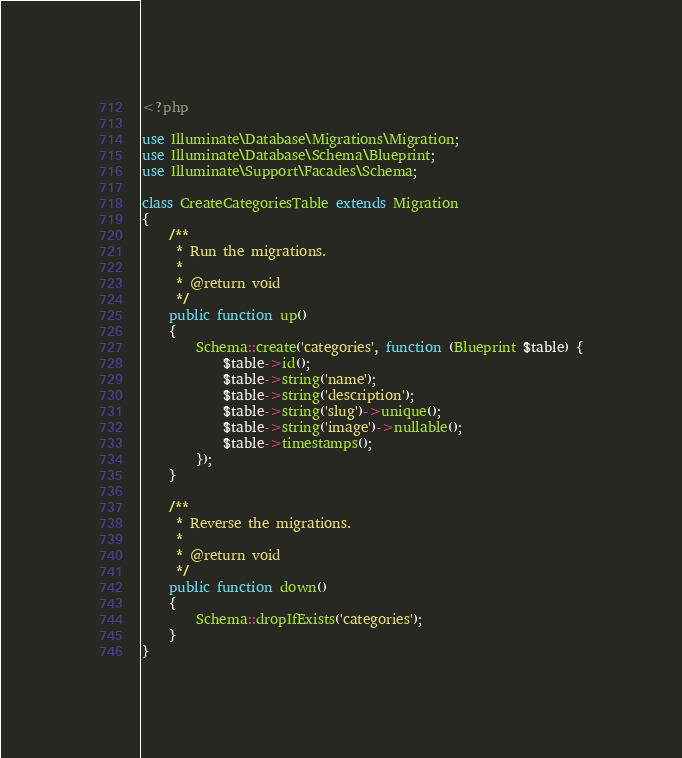Convert code to text. <code><loc_0><loc_0><loc_500><loc_500><_PHP_><?php

use Illuminate\Database\Migrations\Migration;
use Illuminate\Database\Schema\Blueprint;
use Illuminate\Support\Facades\Schema;

class CreateCategoriesTable extends Migration
{
    /**
     * Run the migrations.
     *
     * @return void
     */
    public function up()
    {
        Schema::create('categories', function (Blueprint $table) {
            $table->id();
            $table->string('name');
            $table->string('description');
            $table->string('slug')->unique();
            $table->string('image')->nullable();
            $table->timestamps();
        });
    }

    /**
     * Reverse the migrations.
     *
     * @return void
     */
    public function down()
    {
        Schema::dropIfExists('categories');
    }
}
</code> 